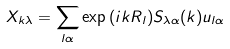Convert formula to latex. <formula><loc_0><loc_0><loc_500><loc_500>X _ { k \lambda } = \sum _ { l \alpha } \exp { ( i k R _ { l } ) } S _ { \lambda \alpha } ( k ) u _ { l \alpha }</formula> 